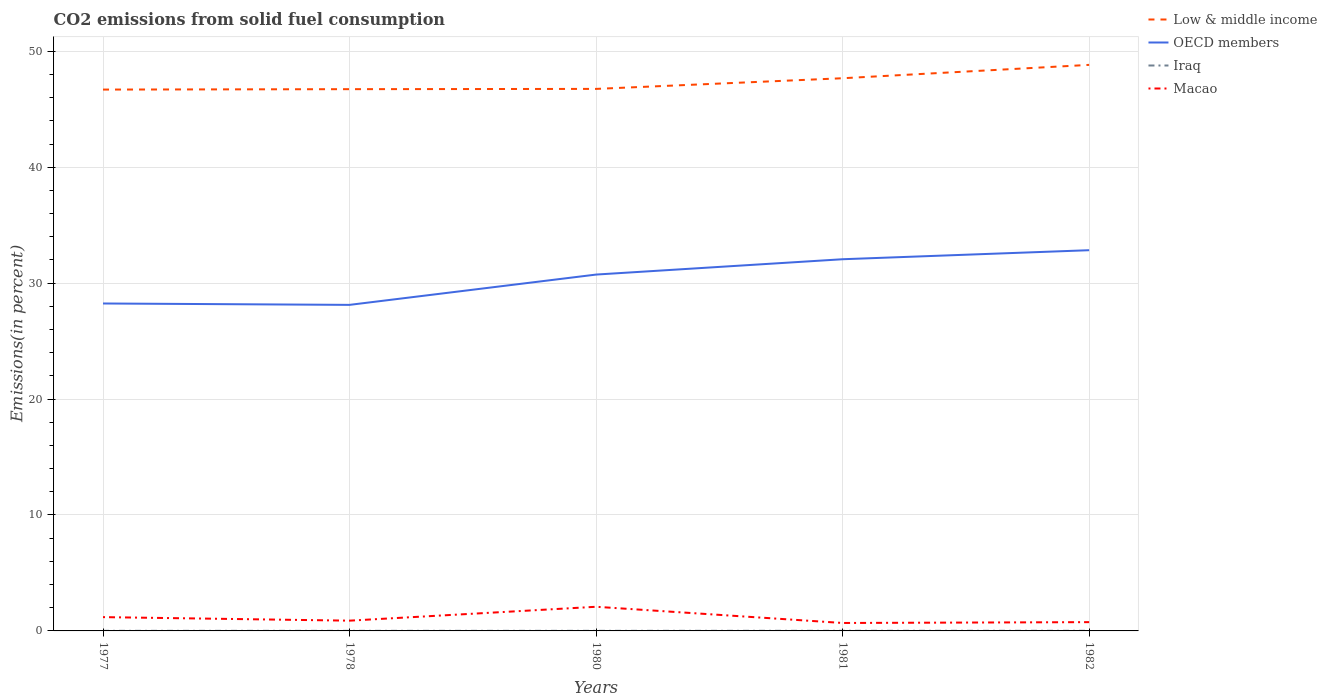Across all years, what is the maximum total CO2 emitted in OECD members?
Ensure brevity in your answer.  28.13. In which year was the total CO2 emitted in Iraq maximum?
Ensure brevity in your answer.  1980. What is the total total CO2 emitted in Macao in the graph?
Keep it short and to the point. -0.07. What is the difference between the highest and the second highest total CO2 emitted in Macao?
Ensure brevity in your answer.  1.4. How many lines are there?
Your answer should be compact. 4. Are the values on the major ticks of Y-axis written in scientific E-notation?
Your response must be concise. No. Does the graph contain any zero values?
Offer a very short reply. No. How are the legend labels stacked?
Make the answer very short. Vertical. What is the title of the graph?
Offer a very short reply. CO2 emissions from solid fuel consumption. What is the label or title of the X-axis?
Your answer should be very brief. Years. What is the label or title of the Y-axis?
Give a very brief answer. Emissions(in percent). What is the Emissions(in percent) in Low & middle income in 1977?
Provide a short and direct response. 46.7. What is the Emissions(in percent) in OECD members in 1977?
Your answer should be compact. 28.24. What is the Emissions(in percent) of Iraq in 1977?
Your answer should be very brief. 0.01. What is the Emissions(in percent) of Macao in 1977?
Your answer should be very brief. 1.19. What is the Emissions(in percent) in Low & middle income in 1978?
Your answer should be compact. 46.73. What is the Emissions(in percent) in OECD members in 1978?
Keep it short and to the point. 28.13. What is the Emissions(in percent) of Iraq in 1978?
Offer a very short reply. 0.01. What is the Emissions(in percent) in Macao in 1978?
Offer a terse response. 0.88. What is the Emissions(in percent) of Low & middle income in 1980?
Provide a short and direct response. 46.76. What is the Emissions(in percent) in OECD members in 1980?
Offer a terse response. 30.74. What is the Emissions(in percent) in Iraq in 1980?
Offer a very short reply. 0.01. What is the Emissions(in percent) of Macao in 1980?
Offer a terse response. 2.08. What is the Emissions(in percent) in Low & middle income in 1981?
Keep it short and to the point. 47.68. What is the Emissions(in percent) of OECD members in 1981?
Provide a succinct answer. 32.06. What is the Emissions(in percent) in Iraq in 1981?
Your answer should be compact. 0.01. What is the Emissions(in percent) in Macao in 1981?
Your answer should be very brief. 0.68. What is the Emissions(in percent) of Low & middle income in 1982?
Offer a terse response. 48.83. What is the Emissions(in percent) in OECD members in 1982?
Give a very brief answer. 32.84. What is the Emissions(in percent) in Iraq in 1982?
Offer a very short reply. 0.01. What is the Emissions(in percent) in Macao in 1982?
Offer a terse response. 0.76. Across all years, what is the maximum Emissions(in percent) of Low & middle income?
Give a very brief answer. 48.83. Across all years, what is the maximum Emissions(in percent) of OECD members?
Your answer should be very brief. 32.84. Across all years, what is the maximum Emissions(in percent) in Iraq?
Give a very brief answer. 0.01. Across all years, what is the maximum Emissions(in percent) of Macao?
Your answer should be compact. 2.08. Across all years, what is the minimum Emissions(in percent) of Low & middle income?
Your answer should be very brief. 46.7. Across all years, what is the minimum Emissions(in percent) in OECD members?
Your answer should be very brief. 28.13. Across all years, what is the minimum Emissions(in percent) in Iraq?
Your answer should be compact. 0.01. Across all years, what is the minimum Emissions(in percent) of Macao?
Offer a terse response. 0.68. What is the total Emissions(in percent) of Low & middle income in the graph?
Your answer should be compact. 236.69. What is the total Emissions(in percent) of OECD members in the graph?
Give a very brief answer. 152.01. What is the total Emissions(in percent) in Iraq in the graph?
Your response must be concise. 0.05. What is the total Emissions(in percent) in Macao in the graph?
Provide a short and direct response. 5.6. What is the difference between the Emissions(in percent) in Low & middle income in 1977 and that in 1978?
Keep it short and to the point. -0.04. What is the difference between the Emissions(in percent) in OECD members in 1977 and that in 1978?
Give a very brief answer. 0.12. What is the difference between the Emissions(in percent) in Iraq in 1977 and that in 1978?
Your response must be concise. -0. What is the difference between the Emissions(in percent) in Macao in 1977 and that in 1978?
Provide a succinct answer. 0.31. What is the difference between the Emissions(in percent) in Low & middle income in 1977 and that in 1980?
Give a very brief answer. -0.06. What is the difference between the Emissions(in percent) in OECD members in 1977 and that in 1980?
Your answer should be compact. -2.5. What is the difference between the Emissions(in percent) of Macao in 1977 and that in 1980?
Give a very brief answer. -0.89. What is the difference between the Emissions(in percent) of Low & middle income in 1977 and that in 1981?
Provide a short and direct response. -0.98. What is the difference between the Emissions(in percent) in OECD members in 1977 and that in 1981?
Give a very brief answer. -3.82. What is the difference between the Emissions(in percent) in Iraq in 1977 and that in 1981?
Keep it short and to the point. -0. What is the difference between the Emissions(in percent) in Macao in 1977 and that in 1981?
Ensure brevity in your answer.  0.51. What is the difference between the Emissions(in percent) of Low & middle income in 1977 and that in 1982?
Offer a terse response. -2.13. What is the difference between the Emissions(in percent) of OECD members in 1977 and that in 1982?
Offer a terse response. -4.6. What is the difference between the Emissions(in percent) in Iraq in 1977 and that in 1982?
Keep it short and to the point. -0. What is the difference between the Emissions(in percent) of Macao in 1977 and that in 1982?
Offer a very short reply. 0.43. What is the difference between the Emissions(in percent) of Low & middle income in 1978 and that in 1980?
Ensure brevity in your answer.  -0.02. What is the difference between the Emissions(in percent) of OECD members in 1978 and that in 1980?
Provide a short and direct response. -2.61. What is the difference between the Emissions(in percent) in Iraq in 1978 and that in 1980?
Your response must be concise. 0. What is the difference between the Emissions(in percent) in Macao in 1978 and that in 1980?
Your response must be concise. -1.2. What is the difference between the Emissions(in percent) in Low & middle income in 1978 and that in 1981?
Ensure brevity in your answer.  -0.94. What is the difference between the Emissions(in percent) in OECD members in 1978 and that in 1981?
Your answer should be compact. -3.94. What is the difference between the Emissions(in percent) in Iraq in 1978 and that in 1981?
Provide a short and direct response. -0. What is the difference between the Emissions(in percent) in Macao in 1978 and that in 1981?
Provide a succinct answer. 0.2. What is the difference between the Emissions(in percent) of Low & middle income in 1978 and that in 1982?
Give a very brief answer. -2.1. What is the difference between the Emissions(in percent) of OECD members in 1978 and that in 1982?
Ensure brevity in your answer.  -4.72. What is the difference between the Emissions(in percent) of Iraq in 1978 and that in 1982?
Keep it short and to the point. -0. What is the difference between the Emissions(in percent) in Macao in 1978 and that in 1982?
Offer a very short reply. 0.13. What is the difference between the Emissions(in percent) of Low & middle income in 1980 and that in 1981?
Offer a very short reply. -0.92. What is the difference between the Emissions(in percent) of OECD members in 1980 and that in 1981?
Keep it short and to the point. -1.32. What is the difference between the Emissions(in percent) of Iraq in 1980 and that in 1981?
Provide a short and direct response. -0. What is the difference between the Emissions(in percent) in Macao in 1980 and that in 1981?
Provide a short and direct response. 1.4. What is the difference between the Emissions(in percent) in Low & middle income in 1980 and that in 1982?
Your response must be concise. -2.07. What is the difference between the Emissions(in percent) in OECD members in 1980 and that in 1982?
Provide a short and direct response. -2.1. What is the difference between the Emissions(in percent) in Iraq in 1980 and that in 1982?
Provide a succinct answer. -0. What is the difference between the Emissions(in percent) of Macao in 1980 and that in 1982?
Your answer should be compact. 1.33. What is the difference between the Emissions(in percent) in Low & middle income in 1981 and that in 1982?
Your answer should be compact. -1.15. What is the difference between the Emissions(in percent) in OECD members in 1981 and that in 1982?
Make the answer very short. -0.78. What is the difference between the Emissions(in percent) in Iraq in 1981 and that in 1982?
Offer a very short reply. -0. What is the difference between the Emissions(in percent) of Macao in 1981 and that in 1982?
Make the answer very short. -0.07. What is the difference between the Emissions(in percent) in Low & middle income in 1977 and the Emissions(in percent) in OECD members in 1978?
Ensure brevity in your answer.  18.57. What is the difference between the Emissions(in percent) in Low & middle income in 1977 and the Emissions(in percent) in Iraq in 1978?
Provide a short and direct response. 46.69. What is the difference between the Emissions(in percent) in Low & middle income in 1977 and the Emissions(in percent) in Macao in 1978?
Provide a short and direct response. 45.81. What is the difference between the Emissions(in percent) of OECD members in 1977 and the Emissions(in percent) of Iraq in 1978?
Offer a terse response. 28.24. What is the difference between the Emissions(in percent) in OECD members in 1977 and the Emissions(in percent) in Macao in 1978?
Offer a terse response. 27.36. What is the difference between the Emissions(in percent) of Iraq in 1977 and the Emissions(in percent) of Macao in 1978?
Provide a short and direct response. -0.88. What is the difference between the Emissions(in percent) of Low & middle income in 1977 and the Emissions(in percent) of OECD members in 1980?
Your answer should be very brief. 15.96. What is the difference between the Emissions(in percent) in Low & middle income in 1977 and the Emissions(in percent) in Iraq in 1980?
Offer a terse response. 46.69. What is the difference between the Emissions(in percent) of Low & middle income in 1977 and the Emissions(in percent) of Macao in 1980?
Make the answer very short. 44.61. What is the difference between the Emissions(in percent) in OECD members in 1977 and the Emissions(in percent) in Iraq in 1980?
Your response must be concise. 28.24. What is the difference between the Emissions(in percent) in OECD members in 1977 and the Emissions(in percent) in Macao in 1980?
Offer a terse response. 26.16. What is the difference between the Emissions(in percent) in Iraq in 1977 and the Emissions(in percent) in Macao in 1980?
Provide a short and direct response. -2.07. What is the difference between the Emissions(in percent) in Low & middle income in 1977 and the Emissions(in percent) in OECD members in 1981?
Provide a short and direct response. 14.63. What is the difference between the Emissions(in percent) of Low & middle income in 1977 and the Emissions(in percent) of Iraq in 1981?
Make the answer very short. 46.69. What is the difference between the Emissions(in percent) in Low & middle income in 1977 and the Emissions(in percent) in Macao in 1981?
Your answer should be very brief. 46.01. What is the difference between the Emissions(in percent) in OECD members in 1977 and the Emissions(in percent) in Iraq in 1981?
Your answer should be very brief. 28.23. What is the difference between the Emissions(in percent) of OECD members in 1977 and the Emissions(in percent) of Macao in 1981?
Offer a very short reply. 27.56. What is the difference between the Emissions(in percent) of Iraq in 1977 and the Emissions(in percent) of Macao in 1981?
Your answer should be compact. -0.68. What is the difference between the Emissions(in percent) of Low & middle income in 1977 and the Emissions(in percent) of OECD members in 1982?
Ensure brevity in your answer.  13.86. What is the difference between the Emissions(in percent) of Low & middle income in 1977 and the Emissions(in percent) of Iraq in 1982?
Your answer should be compact. 46.69. What is the difference between the Emissions(in percent) of Low & middle income in 1977 and the Emissions(in percent) of Macao in 1982?
Your answer should be very brief. 45.94. What is the difference between the Emissions(in percent) of OECD members in 1977 and the Emissions(in percent) of Iraq in 1982?
Your answer should be very brief. 28.23. What is the difference between the Emissions(in percent) in OECD members in 1977 and the Emissions(in percent) in Macao in 1982?
Provide a short and direct response. 27.49. What is the difference between the Emissions(in percent) of Iraq in 1977 and the Emissions(in percent) of Macao in 1982?
Offer a terse response. -0.75. What is the difference between the Emissions(in percent) in Low & middle income in 1978 and the Emissions(in percent) in OECD members in 1980?
Your answer should be very brief. 15.99. What is the difference between the Emissions(in percent) of Low & middle income in 1978 and the Emissions(in percent) of Iraq in 1980?
Your answer should be compact. 46.72. What is the difference between the Emissions(in percent) in Low & middle income in 1978 and the Emissions(in percent) in Macao in 1980?
Make the answer very short. 44.65. What is the difference between the Emissions(in percent) of OECD members in 1978 and the Emissions(in percent) of Iraq in 1980?
Make the answer very short. 28.12. What is the difference between the Emissions(in percent) of OECD members in 1978 and the Emissions(in percent) of Macao in 1980?
Provide a short and direct response. 26.04. What is the difference between the Emissions(in percent) in Iraq in 1978 and the Emissions(in percent) in Macao in 1980?
Keep it short and to the point. -2.07. What is the difference between the Emissions(in percent) of Low & middle income in 1978 and the Emissions(in percent) of OECD members in 1981?
Ensure brevity in your answer.  14.67. What is the difference between the Emissions(in percent) in Low & middle income in 1978 and the Emissions(in percent) in Iraq in 1981?
Your answer should be compact. 46.72. What is the difference between the Emissions(in percent) in Low & middle income in 1978 and the Emissions(in percent) in Macao in 1981?
Your answer should be very brief. 46.05. What is the difference between the Emissions(in percent) of OECD members in 1978 and the Emissions(in percent) of Iraq in 1981?
Offer a very short reply. 28.11. What is the difference between the Emissions(in percent) of OECD members in 1978 and the Emissions(in percent) of Macao in 1981?
Keep it short and to the point. 27.44. What is the difference between the Emissions(in percent) of Iraq in 1978 and the Emissions(in percent) of Macao in 1981?
Your answer should be compact. -0.68. What is the difference between the Emissions(in percent) of Low & middle income in 1978 and the Emissions(in percent) of OECD members in 1982?
Your response must be concise. 13.89. What is the difference between the Emissions(in percent) of Low & middle income in 1978 and the Emissions(in percent) of Iraq in 1982?
Ensure brevity in your answer.  46.72. What is the difference between the Emissions(in percent) in Low & middle income in 1978 and the Emissions(in percent) in Macao in 1982?
Your response must be concise. 45.97. What is the difference between the Emissions(in percent) in OECD members in 1978 and the Emissions(in percent) in Iraq in 1982?
Provide a succinct answer. 28.11. What is the difference between the Emissions(in percent) in OECD members in 1978 and the Emissions(in percent) in Macao in 1982?
Offer a terse response. 27.37. What is the difference between the Emissions(in percent) in Iraq in 1978 and the Emissions(in percent) in Macao in 1982?
Keep it short and to the point. -0.75. What is the difference between the Emissions(in percent) of Low & middle income in 1980 and the Emissions(in percent) of OECD members in 1981?
Offer a terse response. 14.69. What is the difference between the Emissions(in percent) of Low & middle income in 1980 and the Emissions(in percent) of Iraq in 1981?
Offer a very short reply. 46.74. What is the difference between the Emissions(in percent) of Low & middle income in 1980 and the Emissions(in percent) of Macao in 1981?
Offer a very short reply. 46.07. What is the difference between the Emissions(in percent) of OECD members in 1980 and the Emissions(in percent) of Iraq in 1981?
Ensure brevity in your answer.  30.73. What is the difference between the Emissions(in percent) in OECD members in 1980 and the Emissions(in percent) in Macao in 1981?
Your answer should be very brief. 30.05. What is the difference between the Emissions(in percent) in Iraq in 1980 and the Emissions(in percent) in Macao in 1981?
Your answer should be very brief. -0.68. What is the difference between the Emissions(in percent) of Low & middle income in 1980 and the Emissions(in percent) of OECD members in 1982?
Your answer should be compact. 13.91. What is the difference between the Emissions(in percent) in Low & middle income in 1980 and the Emissions(in percent) in Iraq in 1982?
Give a very brief answer. 46.74. What is the difference between the Emissions(in percent) in Low & middle income in 1980 and the Emissions(in percent) in Macao in 1982?
Offer a terse response. 46. What is the difference between the Emissions(in percent) in OECD members in 1980 and the Emissions(in percent) in Iraq in 1982?
Your response must be concise. 30.73. What is the difference between the Emissions(in percent) of OECD members in 1980 and the Emissions(in percent) of Macao in 1982?
Keep it short and to the point. 29.98. What is the difference between the Emissions(in percent) of Iraq in 1980 and the Emissions(in percent) of Macao in 1982?
Provide a succinct answer. -0.75. What is the difference between the Emissions(in percent) in Low & middle income in 1981 and the Emissions(in percent) in OECD members in 1982?
Give a very brief answer. 14.83. What is the difference between the Emissions(in percent) of Low & middle income in 1981 and the Emissions(in percent) of Iraq in 1982?
Your answer should be very brief. 47.66. What is the difference between the Emissions(in percent) of Low & middle income in 1981 and the Emissions(in percent) of Macao in 1982?
Your response must be concise. 46.92. What is the difference between the Emissions(in percent) of OECD members in 1981 and the Emissions(in percent) of Iraq in 1982?
Ensure brevity in your answer.  32.05. What is the difference between the Emissions(in percent) of OECD members in 1981 and the Emissions(in percent) of Macao in 1982?
Make the answer very short. 31.3. What is the difference between the Emissions(in percent) of Iraq in 1981 and the Emissions(in percent) of Macao in 1982?
Offer a very short reply. -0.75. What is the average Emissions(in percent) in Low & middle income per year?
Offer a very short reply. 47.34. What is the average Emissions(in percent) of OECD members per year?
Your answer should be compact. 30.4. What is the average Emissions(in percent) of Iraq per year?
Offer a terse response. 0.01. What is the average Emissions(in percent) in Macao per year?
Make the answer very short. 1.12. In the year 1977, what is the difference between the Emissions(in percent) of Low & middle income and Emissions(in percent) of OECD members?
Your answer should be compact. 18.45. In the year 1977, what is the difference between the Emissions(in percent) of Low & middle income and Emissions(in percent) of Iraq?
Your answer should be very brief. 46.69. In the year 1977, what is the difference between the Emissions(in percent) in Low & middle income and Emissions(in percent) in Macao?
Offer a terse response. 45.51. In the year 1977, what is the difference between the Emissions(in percent) of OECD members and Emissions(in percent) of Iraq?
Your answer should be compact. 28.24. In the year 1977, what is the difference between the Emissions(in percent) of OECD members and Emissions(in percent) of Macao?
Offer a terse response. 27.05. In the year 1977, what is the difference between the Emissions(in percent) in Iraq and Emissions(in percent) in Macao?
Offer a very short reply. -1.18. In the year 1978, what is the difference between the Emissions(in percent) of Low & middle income and Emissions(in percent) of OECD members?
Make the answer very short. 18.61. In the year 1978, what is the difference between the Emissions(in percent) of Low & middle income and Emissions(in percent) of Iraq?
Ensure brevity in your answer.  46.72. In the year 1978, what is the difference between the Emissions(in percent) of Low & middle income and Emissions(in percent) of Macao?
Your answer should be very brief. 45.85. In the year 1978, what is the difference between the Emissions(in percent) in OECD members and Emissions(in percent) in Iraq?
Keep it short and to the point. 28.12. In the year 1978, what is the difference between the Emissions(in percent) in OECD members and Emissions(in percent) in Macao?
Offer a terse response. 27.24. In the year 1978, what is the difference between the Emissions(in percent) in Iraq and Emissions(in percent) in Macao?
Offer a very short reply. -0.88. In the year 1980, what is the difference between the Emissions(in percent) in Low & middle income and Emissions(in percent) in OECD members?
Your response must be concise. 16.02. In the year 1980, what is the difference between the Emissions(in percent) in Low & middle income and Emissions(in percent) in Iraq?
Offer a terse response. 46.75. In the year 1980, what is the difference between the Emissions(in percent) in Low & middle income and Emissions(in percent) in Macao?
Offer a terse response. 44.67. In the year 1980, what is the difference between the Emissions(in percent) of OECD members and Emissions(in percent) of Iraq?
Give a very brief answer. 30.73. In the year 1980, what is the difference between the Emissions(in percent) in OECD members and Emissions(in percent) in Macao?
Offer a terse response. 28.66. In the year 1980, what is the difference between the Emissions(in percent) of Iraq and Emissions(in percent) of Macao?
Your answer should be compact. -2.08. In the year 1981, what is the difference between the Emissions(in percent) of Low & middle income and Emissions(in percent) of OECD members?
Your answer should be compact. 15.61. In the year 1981, what is the difference between the Emissions(in percent) of Low & middle income and Emissions(in percent) of Iraq?
Ensure brevity in your answer.  47.66. In the year 1981, what is the difference between the Emissions(in percent) of Low & middle income and Emissions(in percent) of Macao?
Your answer should be very brief. 46.99. In the year 1981, what is the difference between the Emissions(in percent) of OECD members and Emissions(in percent) of Iraq?
Keep it short and to the point. 32.05. In the year 1981, what is the difference between the Emissions(in percent) of OECD members and Emissions(in percent) of Macao?
Make the answer very short. 31.38. In the year 1981, what is the difference between the Emissions(in percent) of Iraq and Emissions(in percent) of Macao?
Provide a short and direct response. -0.67. In the year 1982, what is the difference between the Emissions(in percent) of Low & middle income and Emissions(in percent) of OECD members?
Give a very brief answer. 15.99. In the year 1982, what is the difference between the Emissions(in percent) of Low & middle income and Emissions(in percent) of Iraq?
Offer a terse response. 48.82. In the year 1982, what is the difference between the Emissions(in percent) of Low & middle income and Emissions(in percent) of Macao?
Your answer should be compact. 48.07. In the year 1982, what is the difference between the Emissions(in percent) of OECD members and Emissions(in percent) of Iraq?
Your response must be concise. 32.83. In the year 1982, what is the difference between the Emissions(in percent) in OECD members and Emissions(in percent) in Macao?
Keep it short and to the point. 32.08. In the year 1982, what is the difference between the Emissions(in percent) of Iraq and Emissions(in percent) of Macao?
Give a very brief answer. -0.75. What is the ratio of the Emissions(in percent) of Low & middle income in 1977 to that in 1978?
Make the answer very short. 1. What is the ratio of the Emissions(in percent) in Iraq in 1977 to that in 1978?
Provide a short and direct response. 0.97. What is the ratio of the Emissions(in percent) of Macao in 1977 to that in 1978?
Offer a terse response. 1.35. What is the ratio of the Emissions(in percent) of Low & middle income in 1977 to that in 1980?
Keep it short and to the point. 1. What is the ratio of the Emissions(in percent) in OECD members in 1977 to that in 1980?
Make the answer very short. 0.92. What is the ratio of the Emissions(in percent) of Iraq in 1977 to that in 1980?
Keep it short and to the point. 1.04. What is the ratio of the Emissions(in percent) in Macao in 1977 to that in 1980?
Provide a succinct answer. 0.57. What is the ratio of the Emissions(in percent) in Low & middle income in 1977 to that in 1981?
Give a very brief answer. 0.98. What is the ratio of the Emissions(in percent) of OECD members in 1977 to that in 1981?
Provide a short and direct response. 0.88. What is the ratio of the Emissions(in percent) of Iraq in 1977 to that in 1981?
Make the answer very short. 0.73. What is the ratio of the Emissions(in percent) of Macao in 1977 to that in 1981?
Your response must be concise. 1.74. What is the ratio of the Emissions(in percent) of Low & middle income in 1977 to that in 1982?
Offer a very short reply. 0.96. What is the ratio of the Emissions(in percent) in OECD members in 1977 to that in 1982?
Provide a short and direct response. 0.86. What is the ratio of the Emissions(in percent) of Iraq in 1977 to that in 1982?
Offer a terse response. 0.7. What is the ratio of the Emissions(in percent) of Macao in 1977 to that in 1982?
Ensure brevity in your answer.  1.57. What is the ratio of the Emissions(in percent) of OECD members in 1978 to that in 1980?
Ensure brevity in your answer.  0.92. What is the ratio of the Emissions(in percent) of Iraq in 1978 to that in 1980?
Ensure brevity in your answer.  1.08. What is the ratio of the Emissions(in percent) in Macao in 1978 to that in 1980?
Ensure brevity in your answer.  0.42. What is the ratio of the Emissions(in percent) of Low & middle income in 1978 to that in 1981?
Provide a succinct answer. 0.98. What is the ratio of the Emissions(in percent) of OECD members in 1978 to that in 1981?
Give a very brief answer. 0.88. What is the ratio of the Emissions(in percent) of Iraq in 1978 to that in 1981?
Your answer should be compact. 0.76. What is the ratio of the Emissions(in percent) in Macao in 1978 to that in 1981?
Your response must be concise. 1.29. What is the ratio of the Emissions(in percent) in Low & middle income in 1978 to that in 1982?
Your response must be concise. 0.96. What is the ratio of the Emissions(in percent) in OECD members in 1978 to that in 1982?
Give a very brief answer. 0.86. What is the ratio of the Emissions(in percent) of Iraq in 1978 to that in 1982?
Your response must be concise. 0.72. What is the ratio of the Emissions(in percent) of Macao in 1978 to that in 1982?
Your answer should be very brief. 1.17. What is the ratio of the Emissions(in percent) of Low & middle income in 1980 to that in 1981?
Your response must be concise. 0.98. What is the ratio of the Emissions(in percent) of OECD members in 1980 to that in 1981?
Give a very brief answer. 0.96. What is the ratio of the Emissions(in percent) in Iraq in 1980 to that in 1981?
Your answer should be very brief. 0.71. What is the ratio of the Emissions(in percent) in Macao in 1980 to that in 1981?
Provide a short and direct response. 3.04. What is the ratio of the Emissions(in percent) of Low & middle income in 1980 to that in 1982?
Provide a succinct answer. 0.96. What is the ratio of the Emissions(in percent) in OECD members in 1980 to that in 1982?
Provide a short and direct response. 0.94. What is the ratio of the Emissions(in percent) in Iraq in 1980 to that in 1982?
Your answer should be very brief. 0.67. What is the ratio of the Emissions(in percent) in Macao in 1980 to that in 1982?
Make the answer very short. 2.75. What is the ratio of the Emissions(in percent) in Low & middle income in 1981 to that in 1982?
Provide a short and direct response. 0.98. What is the ratio of the Emissions(in percent) of OECD members in 1981 to that in 1982?
Give a very brief answer. 0.98. What is the ratio of the Emissions(in percent) in Iraq in 1981 to that in 1982?
Provide a succinct answer. 0.95. What is the ratio of the Emissions(in percent) in Macao in 1981 to that in 1982?
Provide a short and direct response. 0.9. What is the difference between the highest and the second highest Emissions(in percent) of Low & middle income?
Keep it short and to the point. 1.15. What is the difference between the highest and the second highest Emissions(in percent) in OECD members?
Make the answer very short. 0.78. What is the difference between the highest and the second highest Emissions(in percent) in Iraq?
Keep it short and to the point. 0. What is the difference between the highest and the second highest Emissions(in percent) in Macao?
Keep it short and to the point. 0.89. What is the difference between the highest and the lowest Emissions(in percent) of Low & middle income?
Offer a terse response. 2.13. What is the difference between the highest and the lowest Emissions(in percent) in OECD members?
Your answer should be very brief. 4.72. What is the difference between the highest and the lowest Emissions(in percent) of Iraq?
Offer a terse response. 0. What is the difference between the highest and the lowest Emissions(in percent) in Macao?
Make the answer very short. 1.4. 